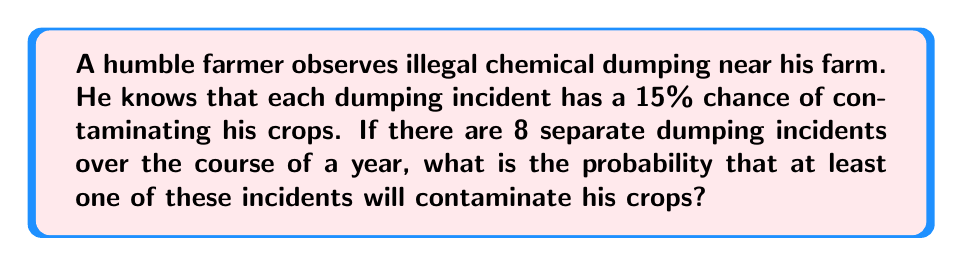Teach me how to tackle this problem. To solve this problem, we'll use the complement rule of probability. Instead of calculating the probability of at least one contamination directly, we'll calculate the probability of no contamination and subtract it from 1.

Let's break it down step-by-step:

1) The probability of a single dumping incident not contaminating the crops is:
   $1 - 0.15 = 0.85$ or $85\%$

2) For all 8 incidents to not cause contamination, each incident must independently not contaminate the crops. We can express this as:
   $$(0.85)^8$$

3) This gives us the probability of no contamination over the 8 incidents. To find the probability of at least one contamination, we subtract this from 1:

   $$P(\text{at least one contamination}) = 1 - P(\text{no contamination})$$
   $$= 1 - (0.85)^8$$

4) Let's calculate this:
   $$(0.85)^8 \approx 0.2725$$

5) Therefore:
   $$1 - 0.2725 = 0.7275$$

So, the probability of at least one contamination is approximately 0.7275 or 72.75%.
Answer: The probability that at least one of the 8 dumping incidents will contaminate the farmer's crops is approximately 0.7275 or 72.75%. 